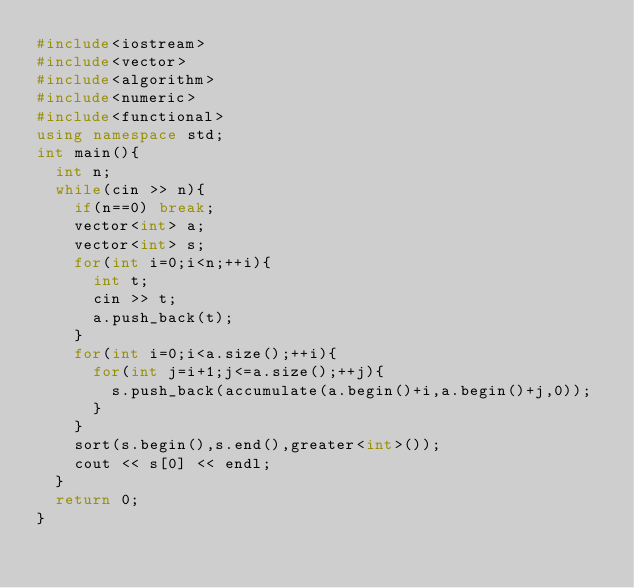<code> <loc_0><loc_0><loc_500><loc_500><_C++_>#include<iostream>
#include<vector>
#include<algorithm>
#include<numeric>
#include<functional>
using namespace std;
int main(){
	int n;
	while(cin >> n){
		if(n==0) break;
		vector<int> a;
		vector<int> s;
		for(int i=0;i<n;++i){
			int t;
			cin >> t;
			a.push_back(t);
		}
		for(int i=0;i<a.size();++i){
			for(int j=i+1;j<=a.size();++j){
				s.push_back(accumulate(a.begin()+i,a.begin()+j,0));
			}
		}
		sort(s.begin(),s.end(),greater<int>());
		cout << s[0] << endl;
	}
	return 0;
}</code> 